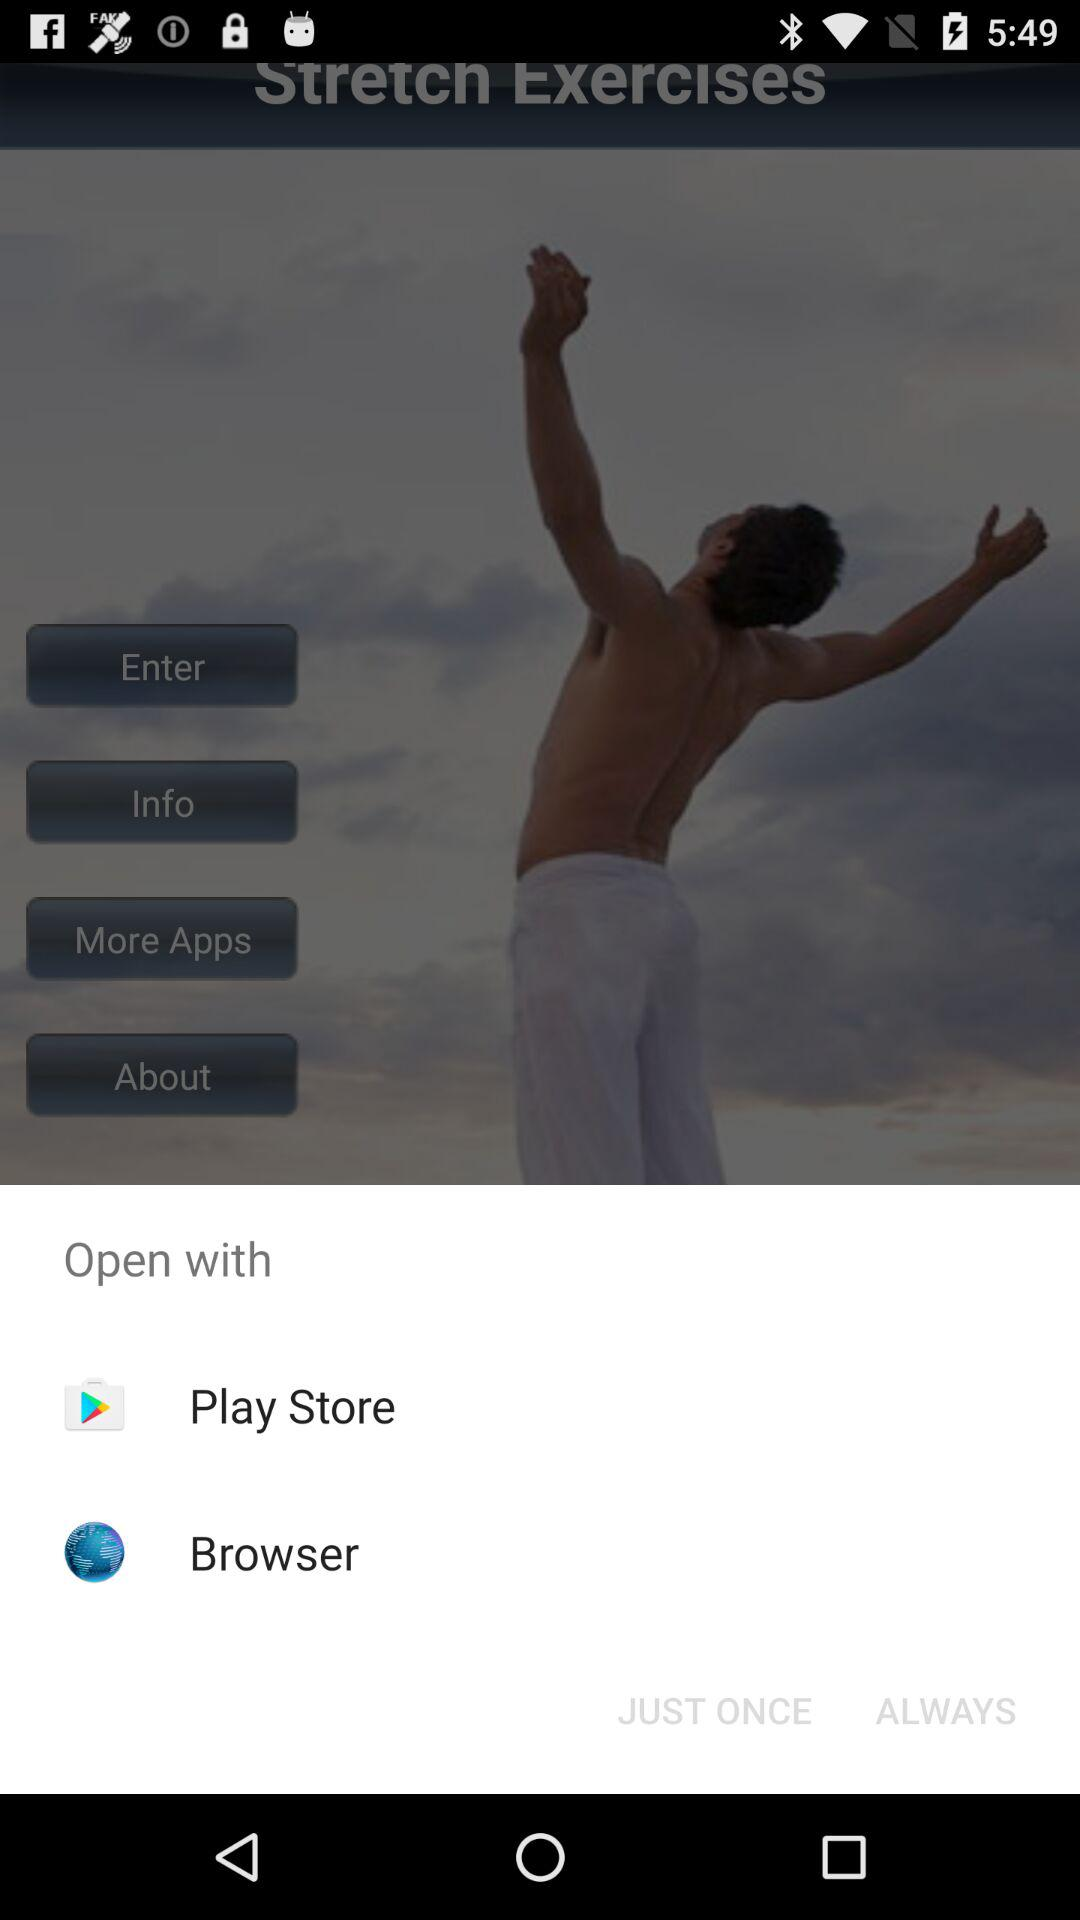How many actions are available to open this app?
Answer the question using a single word or phrase. 2 